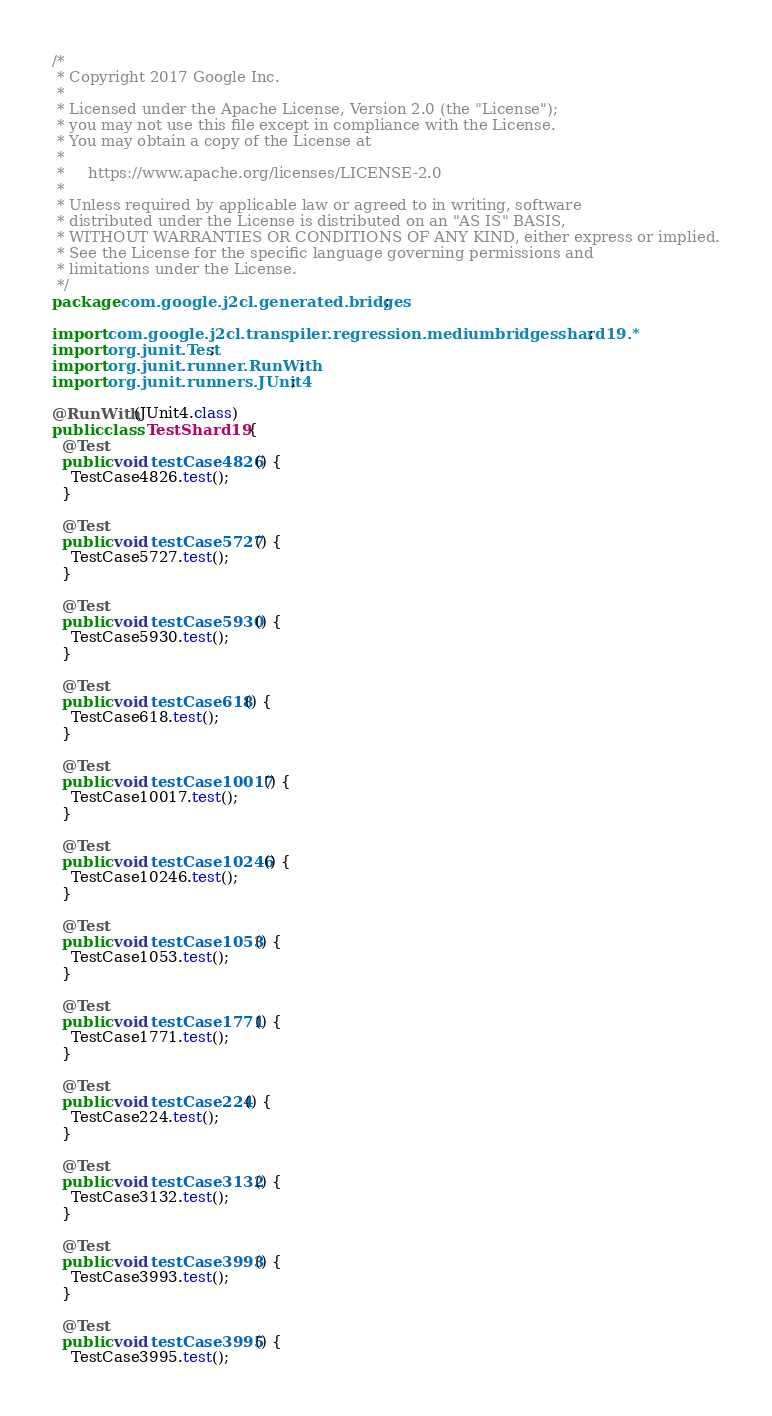Convert code to text. <code><loc_0><loc_0><loc_500><loc_500><_Java_>/*
 * Copyright 2017 Google Inc.
 *
 * Licensed under the Apache License, Version 2.0 (the "License");
 * you may not use this file except in compliance with the License.
 * You may obtain a copy of the License at
 *
 *     https://www.apache.org/licenses/LICENSE-2.0
 *
 * Unless required by applicable law or agreed to in writing, software
 * distributed under the License is distributed on an "AS IS" BASIS,
 * WITHOUT WARRANTIES OR CONDITIONS OF ANY KIND, either express or implied.
 * See the License for the specific language governing permissions and
 * limitations under the License.
 */
package com.google.j2cl.generated.bridges;

import com.google.j2cl.transpiler.regression.mediumbridgesshard19.*;
import org.junit.Test;
import org.junit.runner.RunWith;
import org.junit.runners.JUnit4;

@RunWith(JUnit4.class)
public class TestShard19 {
  @Test
  public void testCase4826() {
    TestCase4826.test();
  }

  @Test
  public void testCase5727() {
    TestCase5727.test();
  }

  @Test
  public void testCase5930() {
    TestCase5930.test();
  }

  @Test
  public void testCase618() {
    TestCase618.test();
  }

  @Test
  public void testCase10017() {
    TestCase10017.test();
  }

  @Test
  public void testCase10246() {
    TestCase10246.test();
  }

  @Test
  public void testCase1053() {
    TestCase1053.test();
  }

  @Test
  public void testCase1771() {
    TestCase1771.test();
  }

  @Test
  public void testCase224() {
    TestCase224.test();
  }

  @Test
  public void testCase3132() {
    TestCase3132.test();
  }

  @Test
  public void testCase3993() {
    TestCase3993.test();
  }

  @Test
  public void testCase3995() {
    TestCase3995.test();</code> 